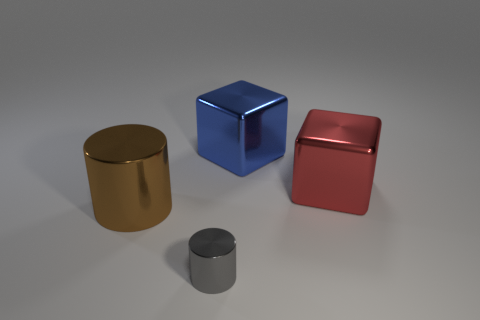There is a shiny cube on the left side of the big object right of the large blue block; what size is it? The cube on the left side of the large object, which is to the right of the blue block, appears to be medium-sized compared to the other objects in the image. 